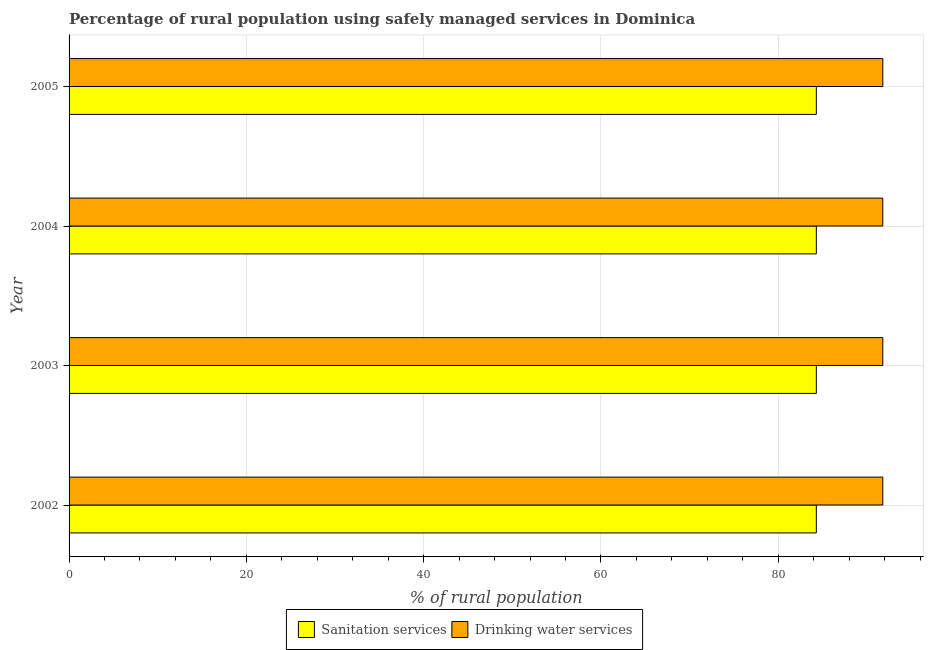How many different coloured bars are there?
Your answer should be very brief. 2. Are the number of bars per tick equal to the number of legend labels?
Your answer should be very brief. Yes. Are the number of bars on each tick of the Y-axis equal?
Offer a very short reply. Yes. How many bars are there on the 3rd tick from the top?
Your response must be concise. 2. How many bars are there on the 4th tick from the bottom?
Provide a succinct answer. 2. In how many cases, is the number of bars for a given year not equal to the number of legend labels?
Ensure brevity in your answer.  0. What is the percentage of rural population who used drinking water services in 2003?
Provide a succinct answer. 91.8. Across all years, what is the maximum percentage of rural population who used sanitation services?
Your answer should be very brief. 84.3. Across all years, what is the minimum percentage of rural population who used sanitation services?
Ensure brevity in your answer.  84.3. In which year was the percentage of rural population who used drinking water services maximum?
Your answer should be compact. 2002. What is the total percentage of rural population who used drinking water services in the graph?
Your response must be concise. 367.2. What is the difference between the percentage of rural population who used drinking water services in 2005 and the percentage of rural population who used sanitation services in 2003?
Your response must be concise. 7.5. What is the average percentage of rural population who used drinking water services per year?
Provide a succinct answer. 91.8. In how many years, is the percentage of rural population who used sanitation services greater than 76 %?
Offer a terse response. 4. What is the ratio of the percentage of rural population who used drinking water services in 2002 to that in 2005?
Provide a short and direct response. 1. Is the percentage of rural population who used sanitation services in 2002 less than that in 2003?
Give a very brief answer. No. Is the difference between the percentage of rural population who used drinking water services in 2003 and 2005 greater than the difference between the percentage of rural population who used sanitation services in 2003 and 2005?
Your response must be concise. No. What is the difference between the highest and the second highest percentage of rural population who used sanitation services?
Ensure brevity in your answer.  0. What is the difference between the highest and the lowest percentage of rural population who used drinking water services?
Keep it short and to the point. 0. In how many years, is the percentage of rural population who used sanitation services greater than the average percentage of rural population who used sanitation services taken over all years?
Your answer should be very brief. 0. What does the 2nd bar from the top in 2005 represents?
Your answer should be compact. Sanitation services. What does the 2nd bar from the bottom in 2004 represents?
Keep it short and to the point. Drinking water services. What is the difference between two consecutive major ticks on the X-axis?
Provide a succinct answer. 20. Are the values on the major ticks of X-axis written in scientific E-notation?
Give a very brief answer. No. Does the graph contain grids?
Keep it short and to the point. Yes. Where does the legend appear in the graph?
Your answer should be compact. Bottom center. How are the legend labels stacked?
Give a very brief answer. Horizontal. What is the title of the graph?
Make the answer very short. Percentage of rural population using safely managed services in Dominica. Does "Rural" appear as one of the legend labels in the graph?
Make the answer very short. No. What is the label or title of the X-axis?
Provide a short and direct response. % of rural population. What is the % of rural population in Sanitation services in 2002?
Offer a very short reply. 84.3. What is the % of rural population in Drinking water services in 2002?
Your answer should be very brief. 91.8. What is the % of rural population of Sanitation services in 2003?
Offer a terse response. 84.3. What is the % of rural population of Drinking water services in 2003?
Your answer should be compact. 91.8. What is the % of rural population in Sanitation services in 2004?
Provide a succinct answer. 84.3. What is the % of rural population in Drinking water services in 2004?
Your response must be concise. 91.8. What is the % of rural population of Sanitation services in 2005?
Keep it short and to the point. 84.3. What is the % of rural population of Drinking water services in 2005?
Keep it short and to the point. 91.8. Across all years, what is the maximum % of rural population of Sanitation services?
Provide a succinct answer. 84.3. Across all years, what is the maximum % of rural population of Drinking water services?
Make the answer very short. 91.8. Across all years, what is the minimum % of rural population in Sanitation services?
Keep it short and to the point. 84.3. Across all years, what is the minimum % of rural population in Drinking water services?
Ensure brevity in your answer.  91.8. What is the total % of rural population in Sanitation services in the graph?
Your answer should be compact. 337.2. What is the total % of rural population in Drinking water services in the graph?
Your answer should be compact. 367.2. What is the difference between the % of rural population of Sanitation services in 2002 and that in 2003?
Your answer should be very brief. 0. What is the difference between the % of rural population of Drinking water services in 2002 and that in 2003?
Offer a very short reply. 0. What is the difference between the % of rural population in Sanitation services in 2002 and that in 2004?
Your answer should be very brief. 0. What is the difference between the % of rural population in Sanitation services in 2002 and that in 2005?
Ensure brevity in your answer.  0. What is the difference between the % of rural population of Drinking water services in 2003 and that in 2005?
Your answer should be very brief. 0. What is the difference between the % of rural population in Sanitation services in 2003 and the % of rural population in Drinking water services in 2004?
Provide a succinct answer. -7.5. What is the difference between the % of rural population of Sanitation services in 2003 and the % of rural population of Drinking water services in 2005?
Offer a terse response. -7.5. What is the difference between the % of rural population of Sanitation services in 2004 and the % of rural population of Drinking water services in 2005?
Keep it short and to the point. -7.5. What is the average % of rural population in Sanitation services per year?
Keep it short and to the point. 84.3. What is the average % of rural population in Drinking water services per year?
Keep it short and to the point. 91.8. In the year 2005, what is the difference between the % of rural population of Sanitation services and % of rural population of Drinking water services?
Provide a succinct answer. -7.5. What is the ratio of the % of rural population of Sanitation services in 2002 to that in 2003?
Give a very brief answer. 1. What is the ratio of the % of rural population in Drinking water services in 2002 to that in 2004?
Give a very brief answer. 1. What is the ratio of the % of rural population in Drinking water services in 2002 to that in 2005?
Offer a terse response. 1. What is the ratio of the % of rural population of Sanitation services in 2003 to that in 2005?
Give a very brief answer. 1. What is the ratio of the % of rural population of Drinking water services in 2003 to that in 2005?
Provide a succinct answer. 1. What is the difference between the highest and the second highest % of rural population of Sanitation services?
Provide a short and direct response. 0. What is the difference between the highest and the second highest % of rural population of Drinking water services?
Provide a short and direct response. 0. What is the difference between the highest and the lowest % of rural population of Drinking water services?
Provide a succinct answer. 0. 